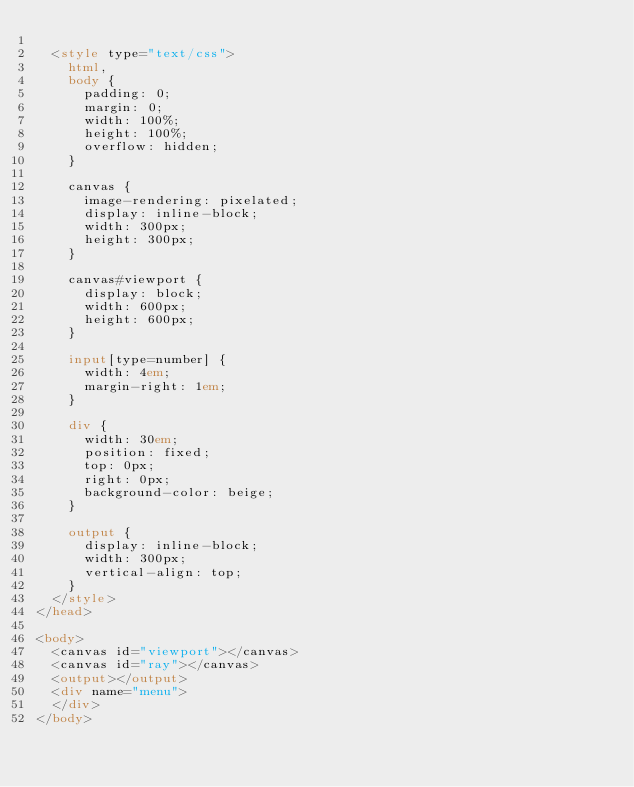Convert code to text. <code><loc_0><loc_0><loc_500><loc_500><_HTML_>
  <style type="text/css">
    html,
    body {
      padding: 0;
      margin: 0;
      width: 100%;
      height: 100%;
      overflow: hidden;
    }

    canvas {
      image-rendering: pixelated;
      display: inline-block;
      width: 300px;
      height: 300px;
    }

    canvas#viewport {
      display: block;
      width: 600px;
      height: 600px;
    }

    input[type=number] {
      width: 4em;
      margin-right: 1em;
    }

    div {
      width: 30em;
      position: fixed;
      top: 0px;
      right: 0px;
      background-color: beige;
    }

    output {
      display: inline-block;
      width: 300px;
      vertical-align: top;
    }
  </style>
</head>

<body>
  <canvas id="viewport"></canvas>
  <canvas id="ray"></canvas>
  <output></output>
  <div name="menu">
  </div>
</body></code> 